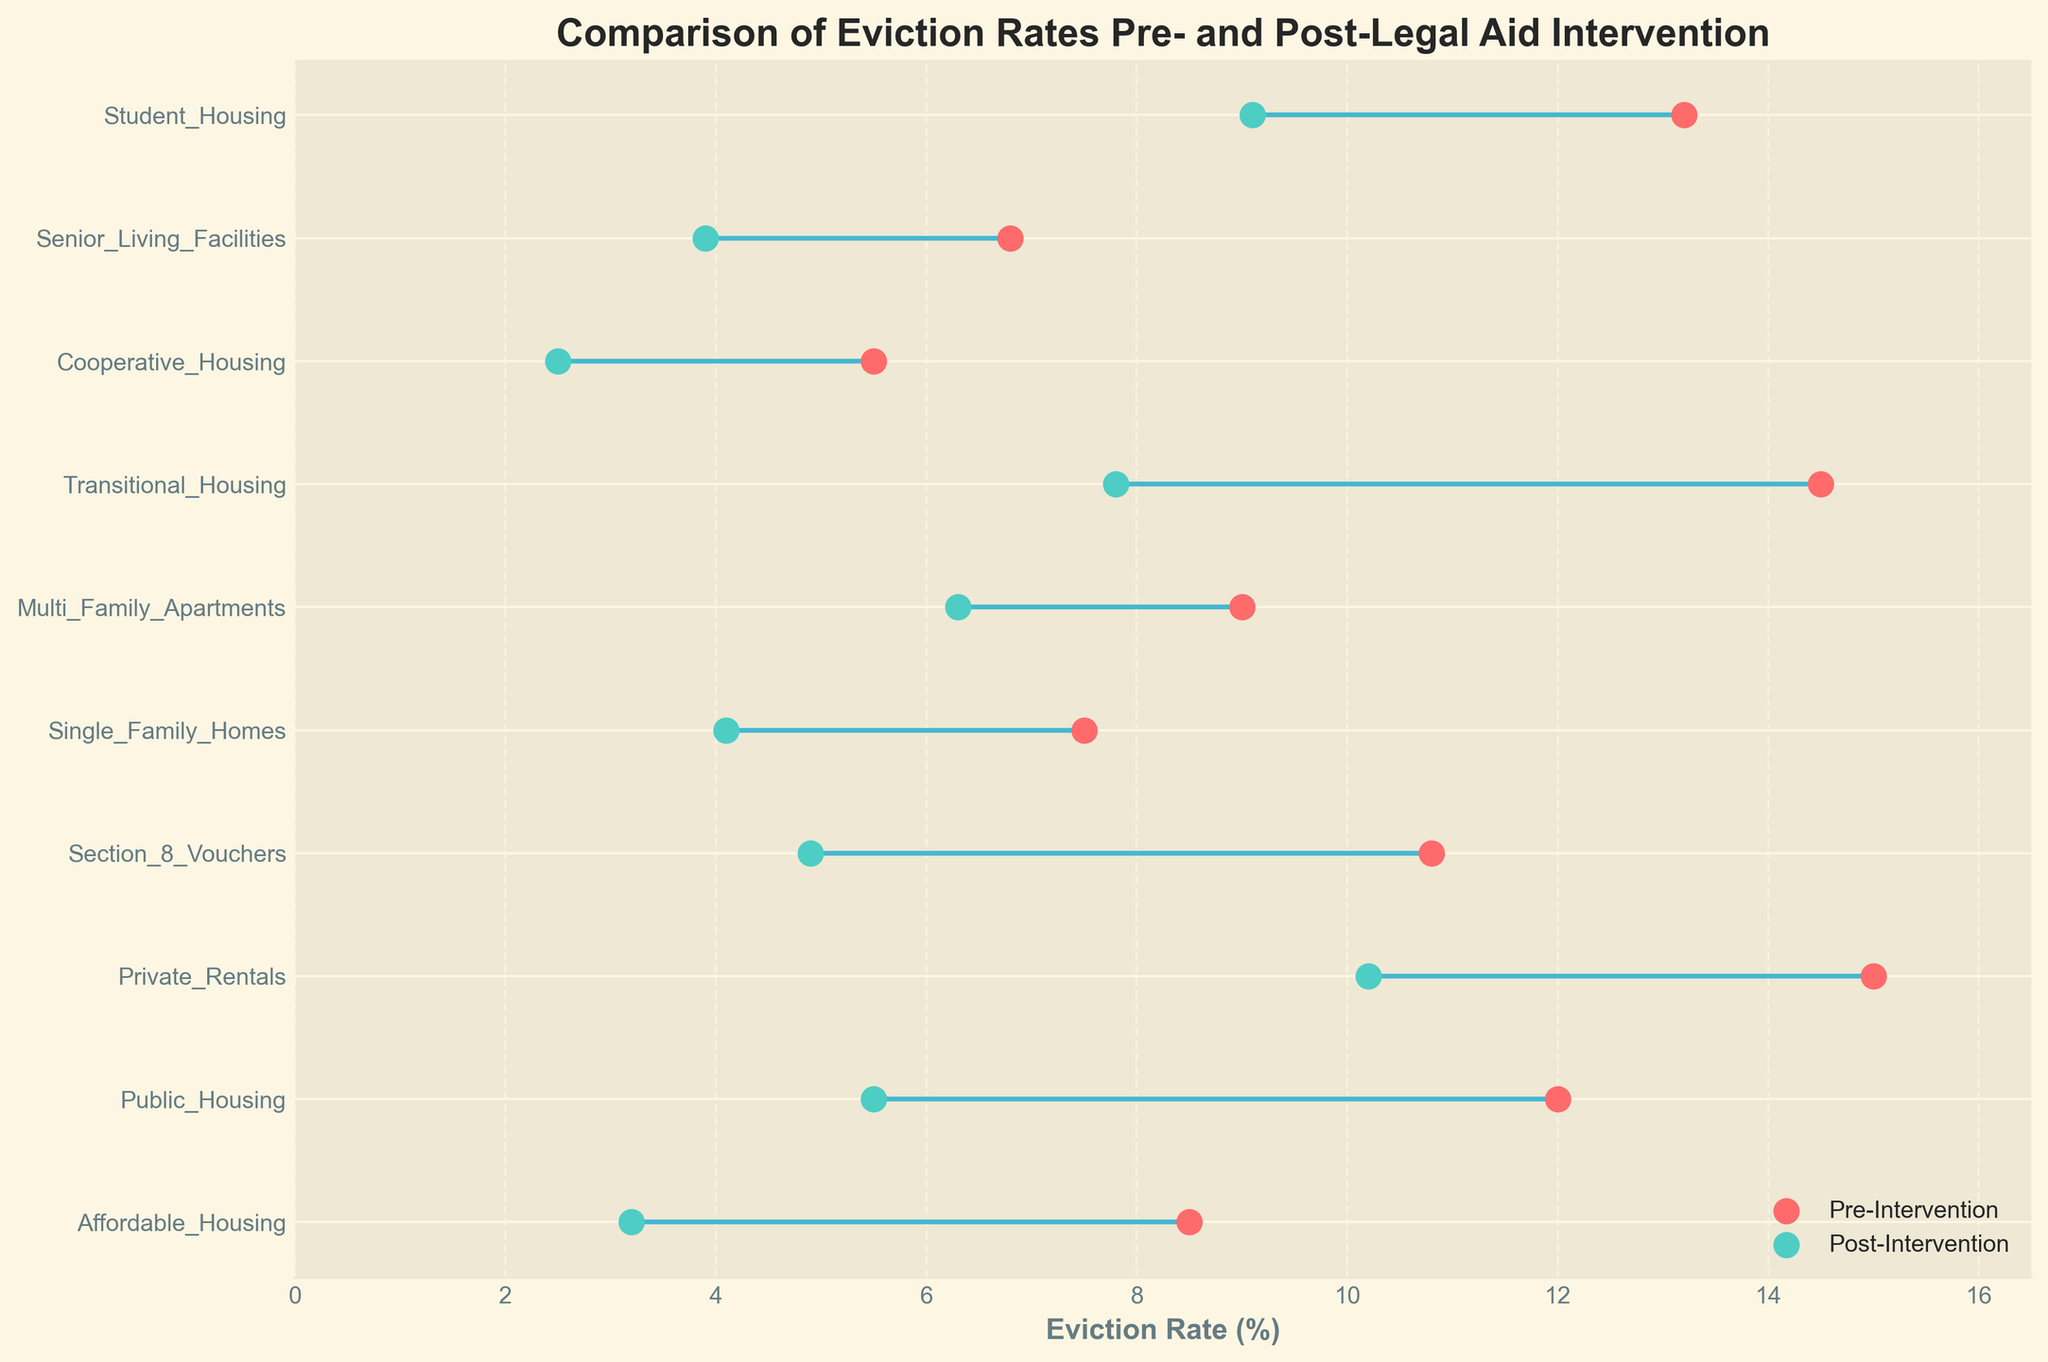What's the title of the figure? The title is typically located at the top of the figure. By reading the text at the top, you can determine the title.
Answer: Comparison of Eviction Rates Pre- and Post-Legal Aid Intervention What are the colors representing different time points? The colors differentiate pre-intervention and post-intervention eviction rates. By observing the legend, the red color (Pre-Intervention) and green color (Post-Intervention) can be seen.
Answer: Red for Pre-Intervention and Green for Post-Intervention How many housing types are compared in the figure? The y-axis labels represent each housing type. Counting the distinct labels provides the number of housing types.
Answer: 10 housing types Which housing type had the highest pre-intervention eviction rate? By looking at the highest dot on the x-axis for the pre-intervention rates, we can identify the housing type associated with it.
Answer: Private Rentals What's the difference in eviction rates for Affordable Housing pre- and post-intervention? Identify the pre- and post-intervention rates for Affordable Housing and calculate the difference: 8.5 (pre) - 3.2 (post) = 5.3
Answer: 5.3 Which housing type experienced the greatest reduction in eviction rates? Calculate the reduction in rates for each housing type and compare them to find the largest reduction. Transitional Housing reduces by 14.5 - 7.8 = 6.7, which is the greatest reduction.
Answer: Transitional Housing What's the average post-intervention eviction rate across all housing types? Sum the post-intervention eviction rates and divide by the number of housing types: (3.2 + 5.5 + 10.2 + 4.9 + 4.1 + 6.3 + 7.8 + 2.5 + 3.9 + 9.1) / 10 = 5.75
Answer: 5.75 Which housing type had nearly the same eviction rates pre- and post-intervention? By comparing the pre- and post-intervention rates, identify the type with minimal difference. Multi-Family Apartments had a small difference: 9.0 (pre) - 6.3 (post) = 2.7.
Answer: Multi-Family Apartments What's the overall change in eviction rates for Cooperative Housing after the intervention? Calculate the change from pre- to post-intervention for Cooperative Housing: 5.5 (pre) - 2.5 (post) = 3.0
Answer: 3.0 Is there any housing type where the post-intervention eviction rate exceeds 10%? Look at the post-intervention eviction rate dots on the x-axis to see if any values exceed 10%. Private Rentals show a post-intervention rate of 10.2.
Answer: Yes, Private Rentals 